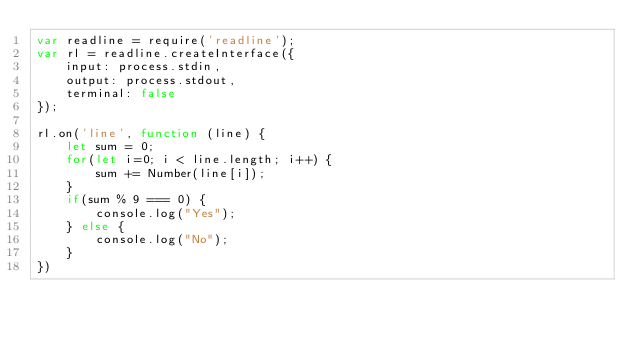<code> <loc_0><loc_0><loc_500><loc_500><_JavaScript_>var readline = require('readline');
var rl = readline.createInterface({
    input: process.stdin,
    output: process.stdout,
    terminal: false
});

rl.on('line', function (line) {
    let sum = 0;
    for(let i=0; i < line.length; i++) {
        sum += Number(line[i]);
    }
    if(sum % 9 === 0) {
        console.log("Yes");
    } else {
        console.log("No");
    }
})</code> 